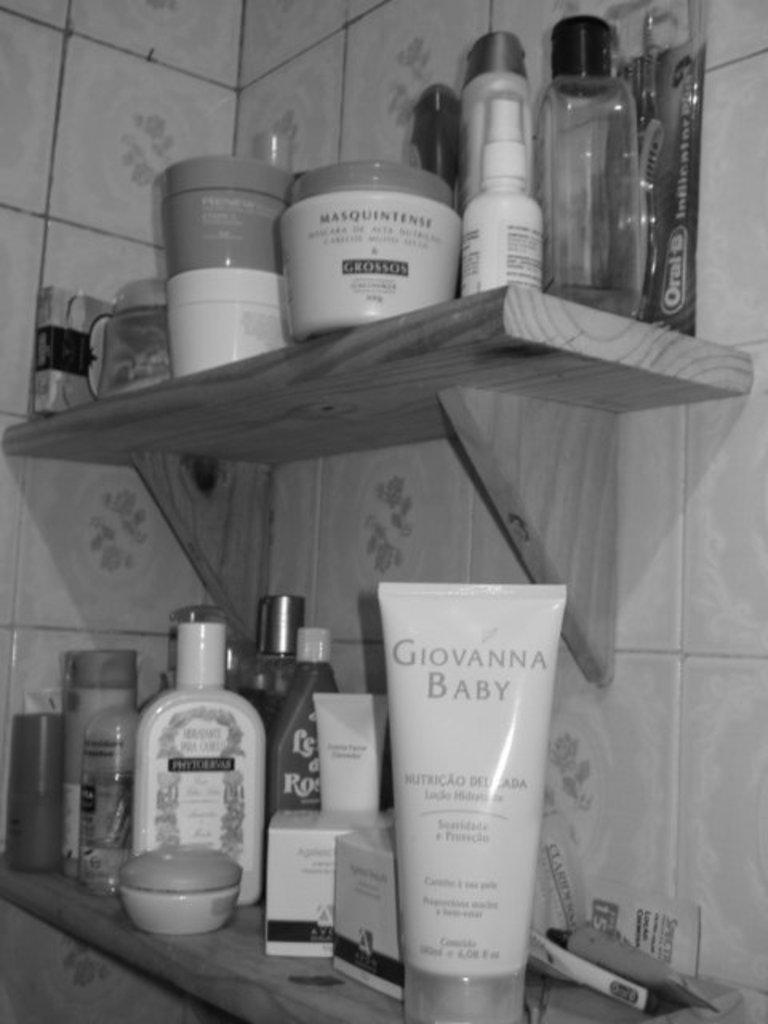What is the color scheme of the image? The image is black and white. What type of items can be seen on the shelves in the image? There are bottles, boxes, and other objects on the shelves. Can you describe the background of the image? There is a wall in the background of the image. Is there an umbrella being used as a railing in the image? There is no umbrella or railing present in the image. How many nails can be seen in the image? There is no mention of nails in the provided facts, so it cannot be determined from the image. 